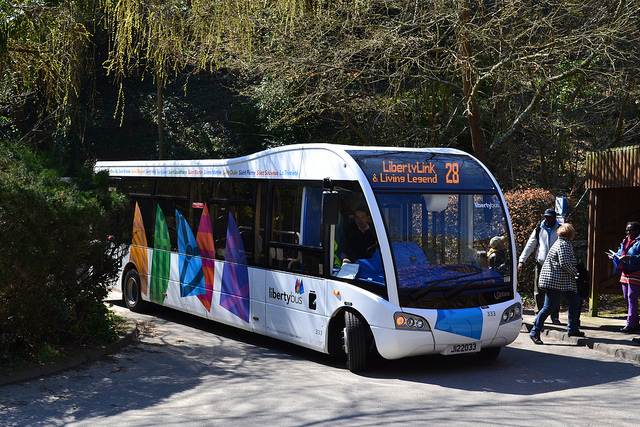Please transcribe the text information in this image. LiberiyLink 28 Living Legend JK22033 